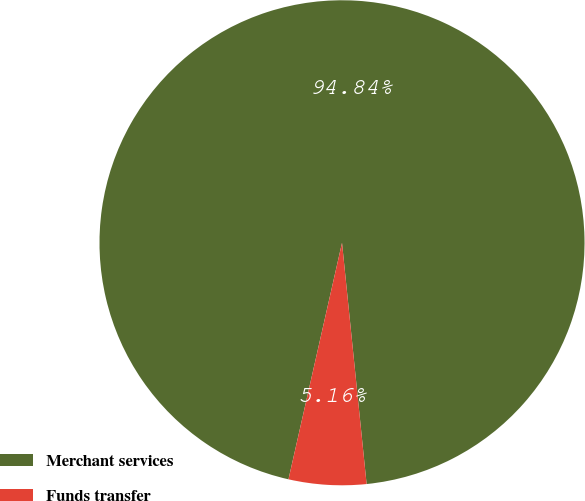Convert chart. <chart><loc_0><loc_0><loc_500><loc_500><pie_chart><fcel>Merchant services<fcel>Funds transfer<nl><fcel>94.84%<fcel>5.16%<nl></chart> 